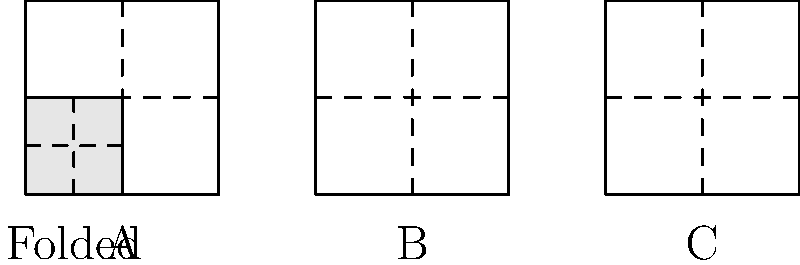As a meticulous language expert with a penchant for plot twists, imagine you're crafting a puzzle for a character in your story. Which of the unfolded shapes (A, B, or C) corresponds to the folded paper pattern shown? Consider how the folds would align and how this puzzle might lead to an unexpected revelation in your narrative. To solve this puzzle, let's analyze the folded and unfolded shapes step-by-step:

1. Observe the folded shape:
   - It's a square with two fold lines, one vertical and one horizontal.
   - These fold lines divide the square into four equal smaller squares.

2. Analyze the unfolded shapes:
   A: A square divided into four equal parts by fold lines.
   B: A square divided into four rectangles by fold lines.
   C: A square divided into four equal parts by fold lines, but with different orientation.

3. Consider the folding process:
   - When unfolded, the shape should be a larger square.
   - The fold lines should divide this larger square into four equal parts.

4. Compare each option:
   A: Matches the criteria perfectly. When folded along the dashed lines, it would create the given folded shape.
   B: Doesn't match. The unequal divisions would not fold into the given shape.
   C: Close, but the orientation of the folds doesn't match the given folded shape.

5. Plot twist consideration:
   The correct answer being the most straightforward option (A) could be used as a misdirection in your narrative, leading to an unexpected twist later.

Therefore, the unfolded shape that corresponds to the folded paper pattern is A.
Answer: A 